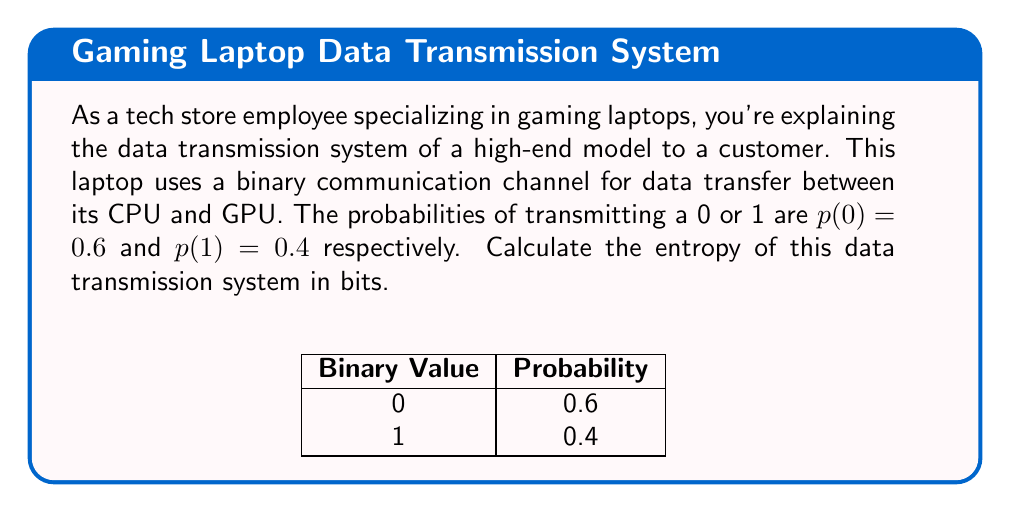Give your solution to this math problem. To calculate the entropy of this binary data transmission system, we'll use the formula for Shannon entropy:

$$H = -\sum_{i=1}^n p(x_i) \log_2 p(x_i)$$

Where:
- $H$ is the entropy
- $p(x_i)$ is the probability of each possible outcome
- $n$ is the number of possible outcomes (in this case, 2 for binary)

Step 1: Calculate the entropy contribution of transmitting a 0:
$$-p(0) \log_2 p(0) = -0.6 \log_2 0.6 \approx 0.4422$$

Step 2: Calculate the entropy contribution of transmitting a 1:
$$-p(1) \log_2 p(1) = -0.4 \log_2 0.4 \approx 0.5288$$

Step 3: Sum the entropy contributions:
$$H = 0.4422 + 0.5288 = 0.971 \text{ bits}$$

This result indicates that each bit transmitted in this system carries, on average, 0.971 bits of information.
Answer: 0.971 bits 